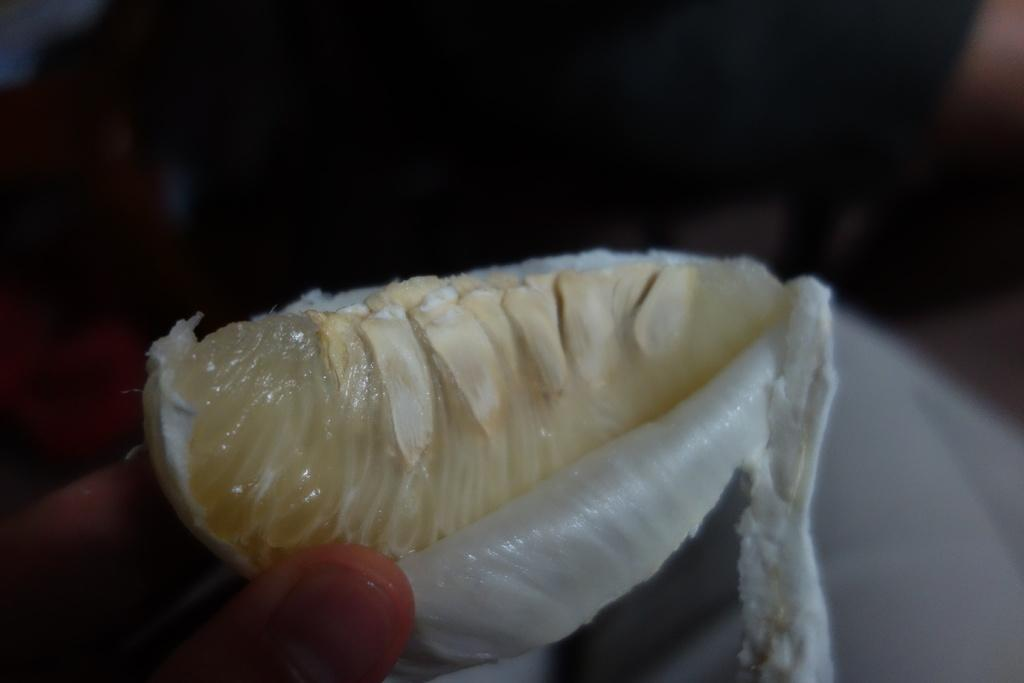What fruit is depicted in the image? There is a slice of an orange in the image. Has the orange been prepared in any way? Yes, the slice of the orange has been peeled off. What color is the tail of the orange in the image? There is no tail present on the orange, as it is a fruit and not an animal. 